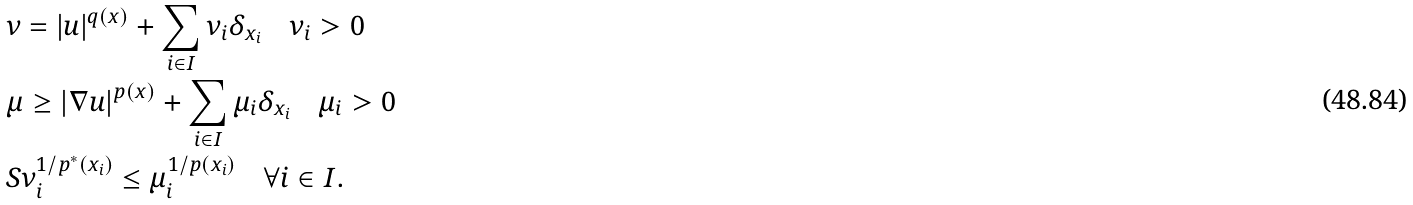Convert formula to latex. <formula><loc_0><loc_0><loc_500><loc_500>& \nu = | u | ^ { q ( x ) } + \sum _ { i \in I } \nu _ { i } \delta _ { x _ { i } } \quad \nu _ { i } > 0 \\ & \mu \geq | \nabla u | ^ { p ( x ) } + \sum _ { i \in I } \mu _ { i } \delta _ { x _ { i } } \quad \mu _ { i } > 0 \\ & S \nu _ { i } ^ { 1 / p ^ { * } ( x _ { i } ) } \leq \mu _ { i } ^ { 1 / p ( x _ { i } ) } \quad \forall i \in I .</formula> 